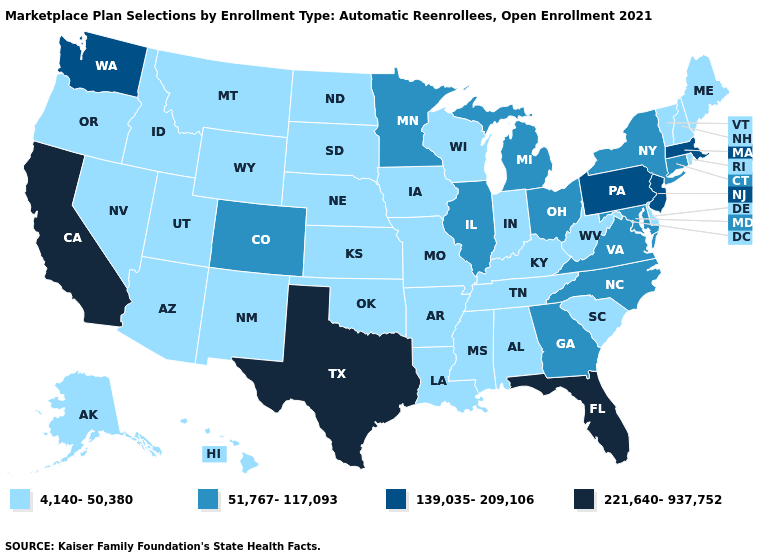Does Pennsylvania have the highest value in the USA?
Give a very brief answer. No. Among the states that border Texas , which have the lowest value?
Answer briefly. Arkansas, Louisiana, New Mexico, Oklahoma. Which states hav the highest value in the South?
Quick response, please. Florida, Texas. What is the value of New Jersey?
Give a very brief answer. 139,035-209,106. What is the lowest value in states that border Oklahoma?
Keep it brief. 4,140-50,380. Name the states that have a value in the range 221,640-937,752?
Give a very brief answer. California, Florida, Texas. Does California have the lowest value in the West?
Give a very brief answer. No. Does the first symbol in the legend represent the smallest category?
Answer briefly. Yes. What is the value of Connecticut?
Short answer required. 51,767-117,093. Name the states that have a value in the range 4,140-50,380?
Write a very short answer. Alabama, Alaska, Arizona, Arkansas, Delaware, Hawaii, Idaho, Indiana, Iowa, Kansas, Kentucky, Louisiana, Maine, Mississippi, Missouri, Montana, Nebraska, Nevada, New Hampshire, New Mexico, North Dakota, Oklahoma, Oregon, Rhode Island, South Carolina, South Dakota, Tennessee, Utah, Vermont, West Virginia, Wisconsin, Wyoming. Does Nebraska have the lowest value in the USA?
Keep it brief. Yes. Does the first symbol in the legend represent the smallest category?
Short answer required. Yes. What is the lowest value in states that border Massachusetts?
Short answer required. 4,140-50,380. 